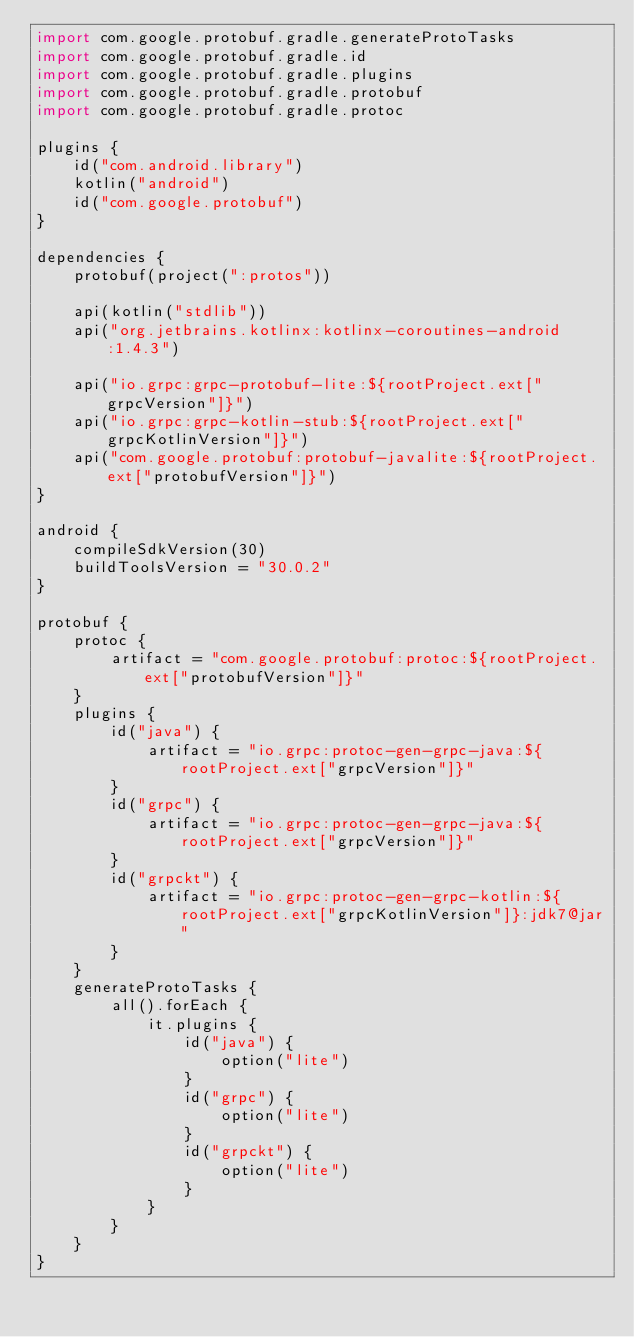Convert code to text. <code><loc_0><loc_0><loc_500><loc_500><_Kotlin_>import com.google.protobuf.gradle.generateProtoTasks
import com.google.protobuf.gradle.id
import com.google.protobuf.gradle.plugins
import com.google.protobuf.gradle.protobuf
import com.google.protobuf.gradle.protoc

plugins {
    id("com.android.library")
    kotlin("android")
    id("com.google.protobuf")
}

dependencies {
    protobuf(project(":protos"))

    api(kotlin("stdlib"))
    api("org.jetbrains.kotlinx:kotlinx-coroutines-android:1.4.3")

    api("io.grpc:grpc-protobuf-lite:${rootProject.ext["grpcVersion"]}")
    api("io.grpc:grpc-kotlin-stub:${rootProject.ext["grpcKotlinVersion"]}")
    api("com.google.protobuf:protobuf-javalite:${rootProject.ext["protobufVersion"]}")
}

android {
    compileSdkVersion(30)
    buildToolsVersion = "30.0.2"
}

protobuf {
    protoc {
        artifact = "com.google.protobuf:protoc:${rootProject.ext["protobufVersion"]}"
    }
    plugins {
        id("java") {
            artifact = "io.grpc:protoc-gen-grpc-java:${rootProject.ext["grpcVersion"]}"
        }
        id("grpc") {
            artifact = "io.grpc:protoc-gen-grpc-java:${rootProject.ext["grpcVersion"]}"
        }
        id("grpckt") {
            artifact = "io.grpc:protoc-gen-grpc-kotlin:${rootProject.ext["grpcKotlinVersion"]}:jdk7@jar"
        }
    }
    generateProtoTasks {
        all().forEach {
            it.plugins {
                id("java") {
                    option("lite")
                }
                id("grpc") {
                    option("lite")
                }
                id("grpckt") {
                    option("lite")
                }
            }
        }
    }
}
</code> 